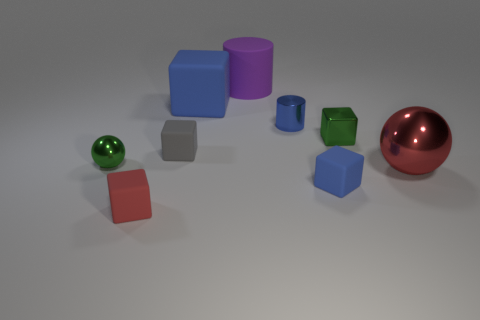Subtract all tiny blocks. How many blocks are left? 1 Add 1 brown matte balls. How many objects exist? 10 Subtract all blocks. How many objects are left? 4 Subtract 1 spheres. How many spheres are left? 1 Subtract all yellow balls. Subtract all cyan cylinders. How many balls are left? 2 Subtract all brown cubes. How many cyan spheres are left? 0 Subtract all gray things. Subtract all tiny gray matte cubes. How many objects are left? 7 Add 4 small gray rubber objects. How many small gray rubber objects are left? 5 Add 7 large purple cylinders. How many large purple cylinders exist? 8 Subtract all gray cubes. How many cubes are left? 4 